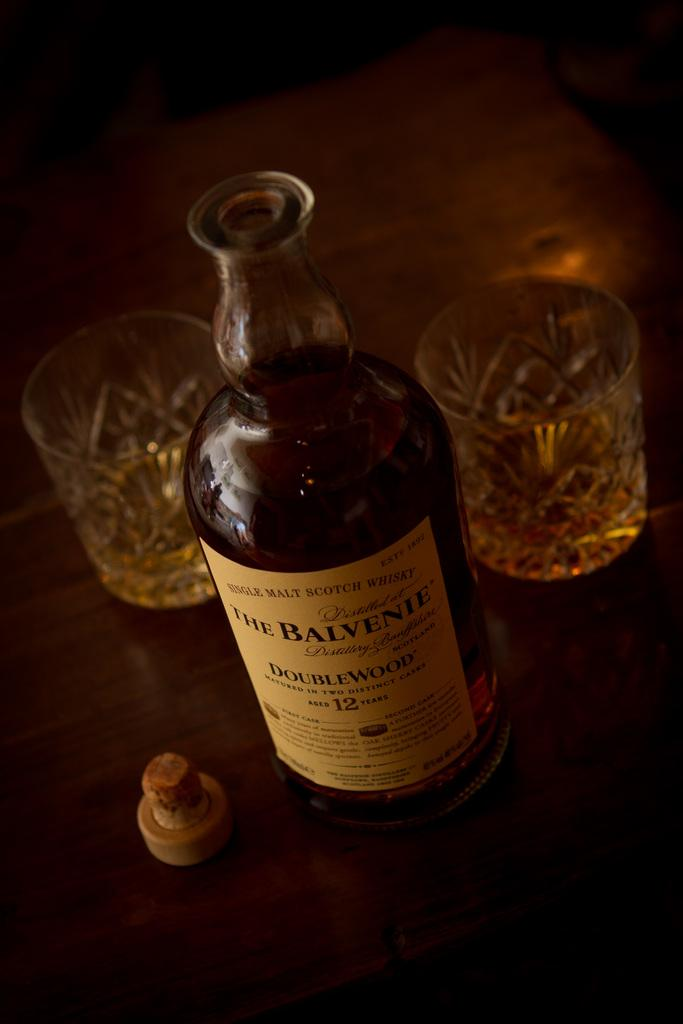What type of bottle is present in the image? There is a whisky bottle in the image. What is the cap associated with in the image? The cap is associated with the whisky bottle in the image. Where are the whisky bottle and cap located? The whisky bottle and cap are placed on a table in the image. How many glasses are on the table in the image? There are two glasses on the table in the image. What type of noise can be heard coming from the hill in the image? There is no hill present in the image, so it is not possible to determine what type of noise might be heard. 